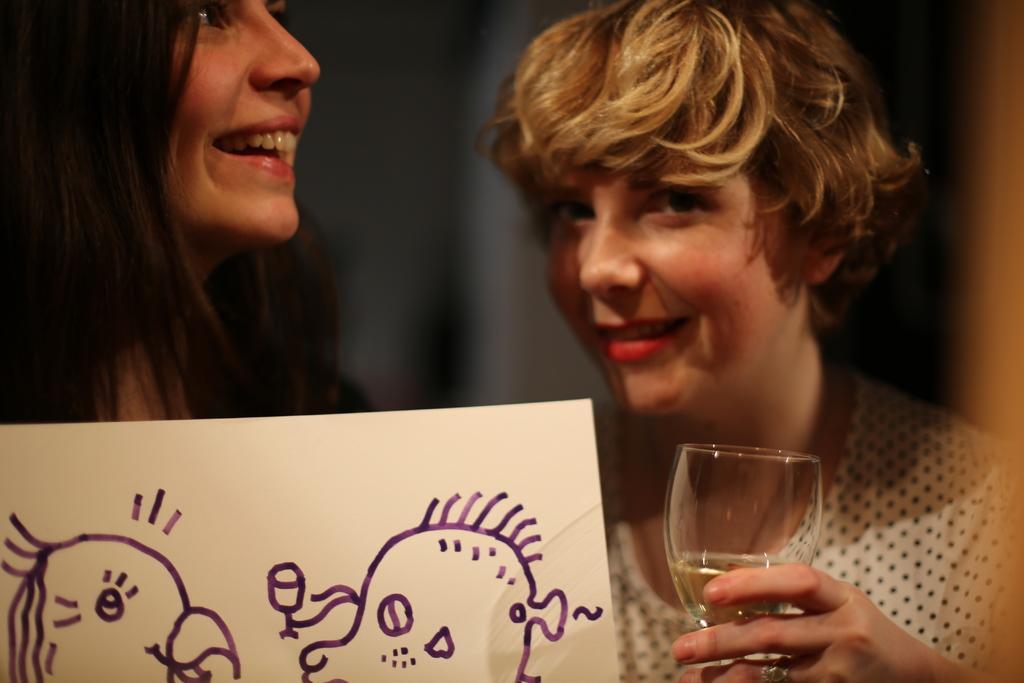Please provide a concise description of this image. This is the picture of two persons, the woman in white dress holding a glass. In front of this people there is a paper with drawing. 